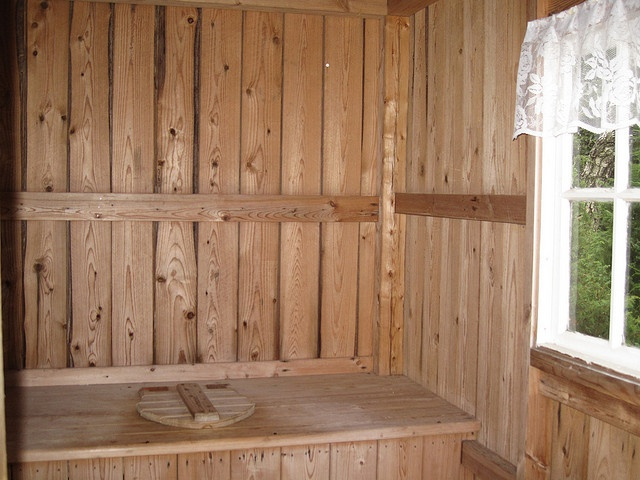Describe the objects in this image and their specific colors. I can see a toilet in black, gray, and brown tones in this image. 